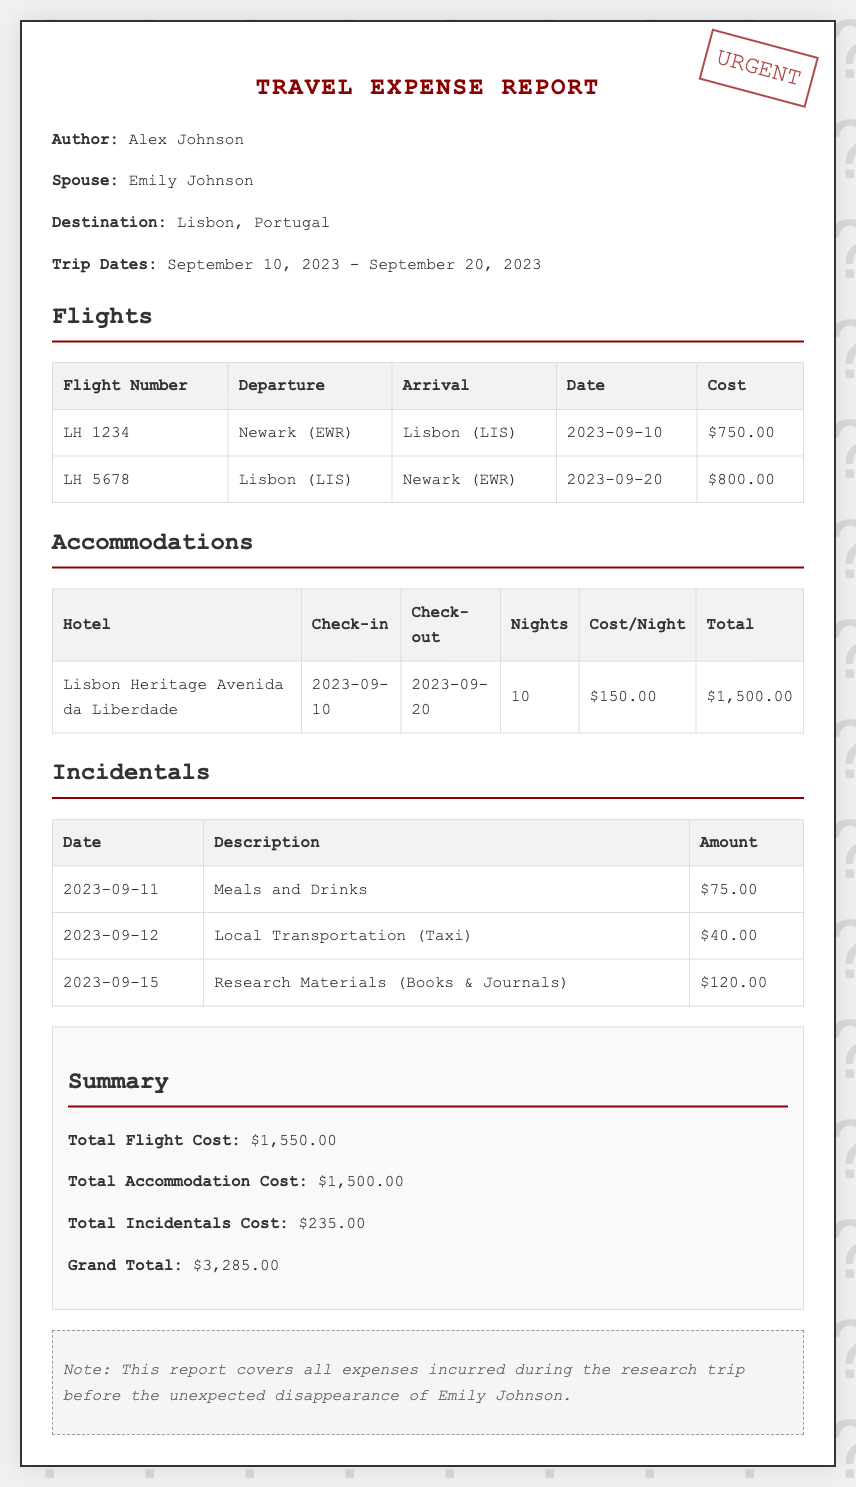what is the name of the author? The author's name is listed under the author section of the report.
Answer: Alex Johnson what is the destination of the trip? The destination is stated near the beginning of the report.
Answer: Lisbon, Portugal how much was the total accommodation cost? The total accommodation cost is found in the summary section of the document.
Answer: $1,500.00 what was the cost of the flight from Newark to Lisbon? The cost of the specific flight is listed in the flights table under the "Cost" column.
Answer: $750.00 how many nights did they stay at the hotel? The total number of nights is recorded in the accommodations table.
Answer: 10 what was spent on research materials? The amount spent on research materials is included in the incidentals table.
Answer: $120.00 what is the grand total of the expenses? The grand total can be found in the summary section where all costs are totaled.
Answer: $3,285.00 when did the trip take place? The trip dates are clearly indicated in the trip dates section of the report.
Answer: September 10, 2023 - September 20, 2023 what is noted about the report? The note at the bottom of the document provides specific information about the circumstances surrounding the expenses.
Answer: Covers all expenses incurred before the unexpected disappearance 